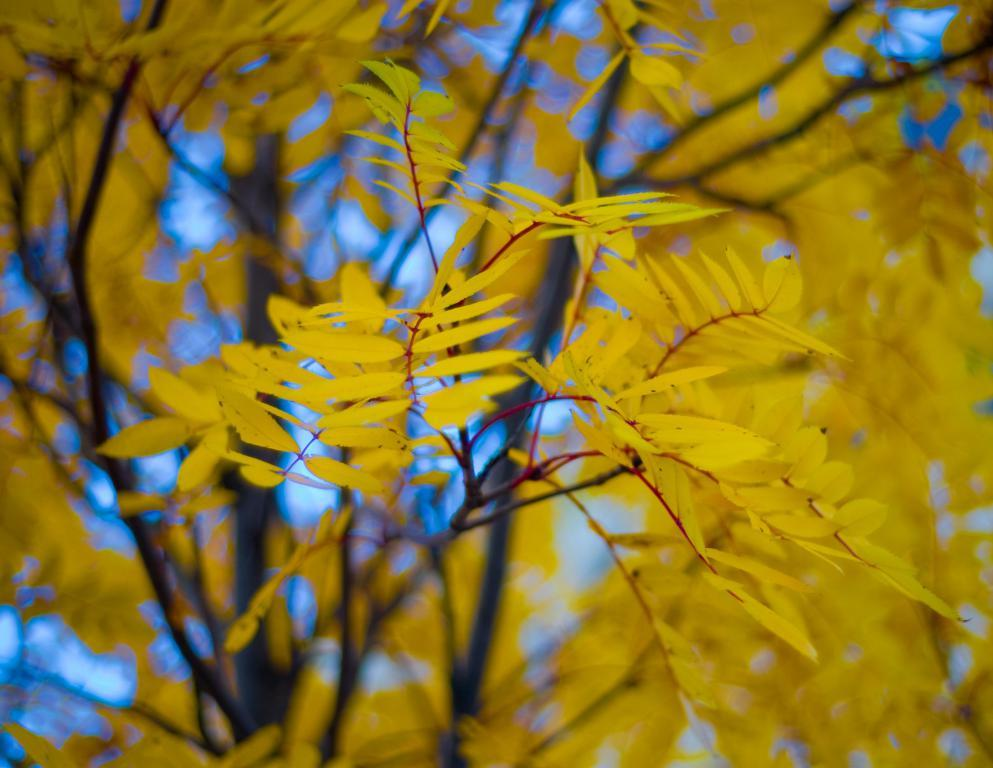What is the main subject of the image? The main subject of the image is a tree. What is unique about the tree's appearance? The tree has yellow color leaves. What can be seen in the background of the image? The blue sky is visible in the background of the image. What type of orange is being peeled in the image? There is no orange present in the image; it features a tree with yellow leaves and a blue sky in the background. 